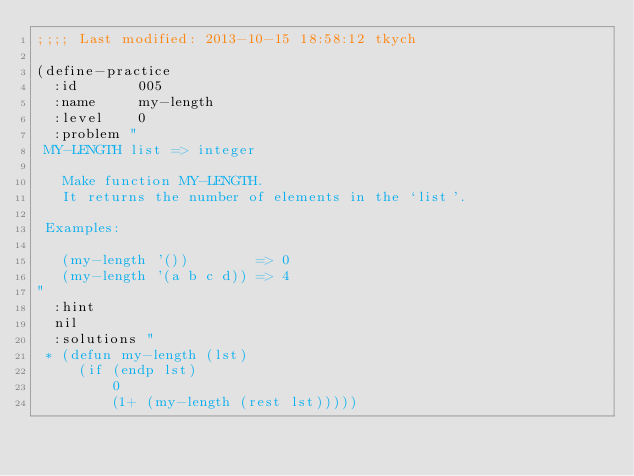Convert code to text. <code><loc_0><loc_0><loc_500><loc_500><_Lisp_>;;;; Last modified: 2013-10-15 18:58:12 tkych

(define-practice
  :id       005
  :name     my-length
  :level    0
  :problem "
 MY-LENGTH list => integer

   Make function MY-LENGTH.
   It returns the number of elements in the `list'.

 Examples:

   (my-length '())        => 0
   (my-length '(a b c d)) => 4
"
  :hint
  nil
  :solutions "
 * (defun my-length (lst)
     (if (endp lst)
         0
         (1+ (my-length (rest lst)))))
</code> 